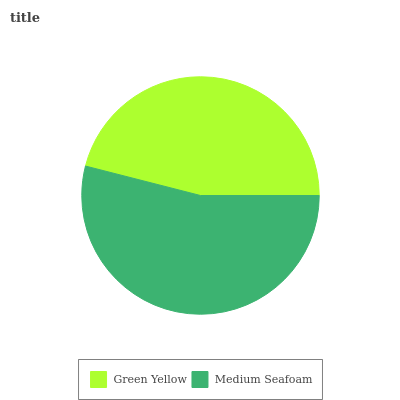Is Green Yellow the minimum?
Answer yes or no. Yes. Is Medium Seafoam the maximum?
Answer yes or no. Yes. Is Medium Seafoam the minimum?
Answer yes or no. No. Is Medium Seafoam greater than Green Yellow?
Answer yes or no. Yes. Is Green Yellow less than Medium Seafoam?
Answer yes or no. Yes. Is Green Yellow greater than Medium Seafoam?
Answer yes or no. No. Is Medium Seafoam less than Green Yellow?
Answer yes or no. No. Is Medium Seafoam the high median?
Answer yes or no. Yes. Is Green Yellow the low median?
Answer yes or no. Yes. Is Green Yellow the high median?
Answer yes or no. No. Is Medium Seafoam the low median?
Answer yes or no. No. 